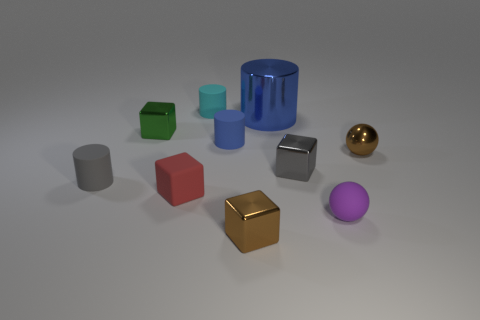What shape is the tiny gray thing that is the same material as the purple sphere?
Provide a succinct answer. Cylinder. There is a thing that is both behind the tiny green cube and left of the big metallic object; what material is it?
Your response must be concise. Rubber. Is there anything else that has the same size as the blue metallic object?
Keep it short and to the point. No. There is a tiny rubber object that is the same color as the metallic cylinder; what is its shape?
Make the answer very short. Cylinder. How many tiny blue objects are the same shape as the tiny purple matte thing?
Keep it short and to the point. 0. What size is the gray cube that is made of the same material as the green object?
Keep it short and to the point. Small. Is the gray block the same size as the shiny cylinder?
Give a very brief answer. No. Are there any small cyan shiny balls?
Offer a terse response. No. What is the size of the blue cylinder that is on the right side of the blue object that is on the left side of the large thing behind the tiny red cube?
Make the answer very short. Large. What number of tiny cyan things are the same material as the tiny cyan cylinder?
Offer a very short reply. 0. 